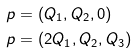<formula> <loc_0><loc_0><loc_500><loc_500>p & = ( Q _ { 1 } , Q _ { 2 } , 0 ) \\ p & = ( 2 Q _ { 1 } , Q _ { 2 } , Q _ { 3 } )</formula> 